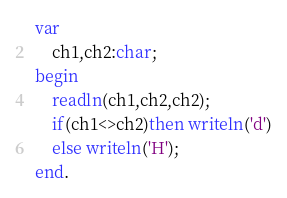Convert code to text. <code><loc_0><loc_0><loc_500><loc_500><_Pascal_>var
    ch1,ch2:char;
begin
    readln(ch1,ch2,ch2);
    if(ch1<>ch2)then writeln('d')
    else writeln('H');
end.
</code> 